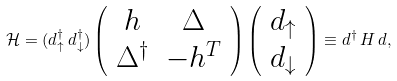<formula> <loc_0><loc_0><loc_500><loc_500>\mathcal { H } = ( d _ { \uparrow } ^ { \dagger } \, d _ { \downarrow } ^ { \dagger } ) \left ( \begin{array} { c c } h & \Delta \\ \Delta ^ { \dagger } & - h ^ { T } \end{array} \right ) \left ( \begin{array} { c } d _ { \uparrow } \\ d _ { \downarrow } \end{array} \right ) \equiv d ^ { \dagger } \, H \, d ,</formula> 